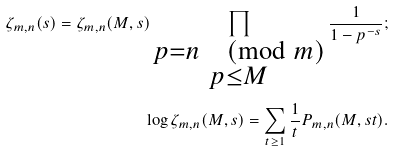<formula> <loc_0><loc_0><loc_500><loc_500>\zeta _ { m , n } ( s ) = \zeta _ { m , n } ( M , s ) \prod _ { \substack { p = n \pmod { m } \\ p \leq M } } \frac { 1 } { 1 - p ^ { - s } } ; \\ \log \zeta _ { m , n } ( M , s ) = \sum _ { t \geq 1 } \frac { 1 } { t } P _ { m , n } ( M , s t ) .</formula> 